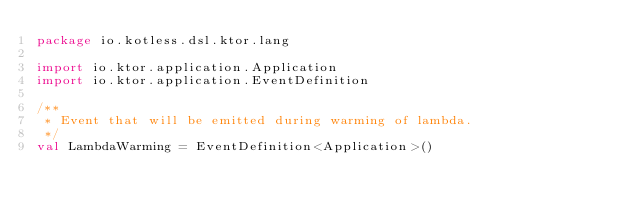<code> <loc_0><loc_0><loc_500><loc_500><_Kotlin_>package io.kotless.dsl.ktor.lang

import io.ktor.application.Application
import io.ktor.application.EventDefinition

/**
 * Event that will be emitted during warming of lambda.
 */
val LambdaWarming = EventDefinition<Application>()
</code> 